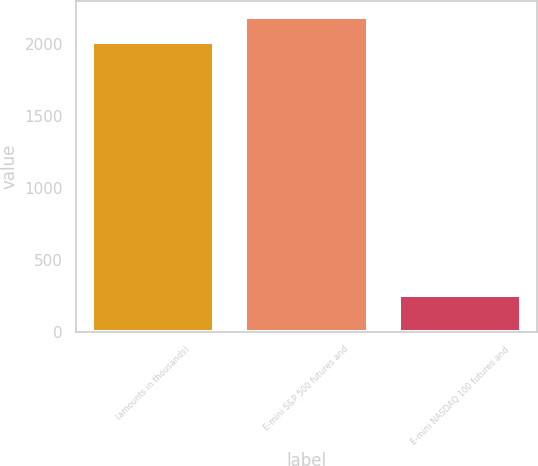<chart> <loc_0><loc_0><loc_500><loc_500><bar_chart><fcel>(amounts in thousands)<fcel>E-mini S&P 500 futures and<fcel>E-mini NASDAQ 100 futures and<nl><fcel>2012<fcel>2188.2<fcel>254<nl></chart> 